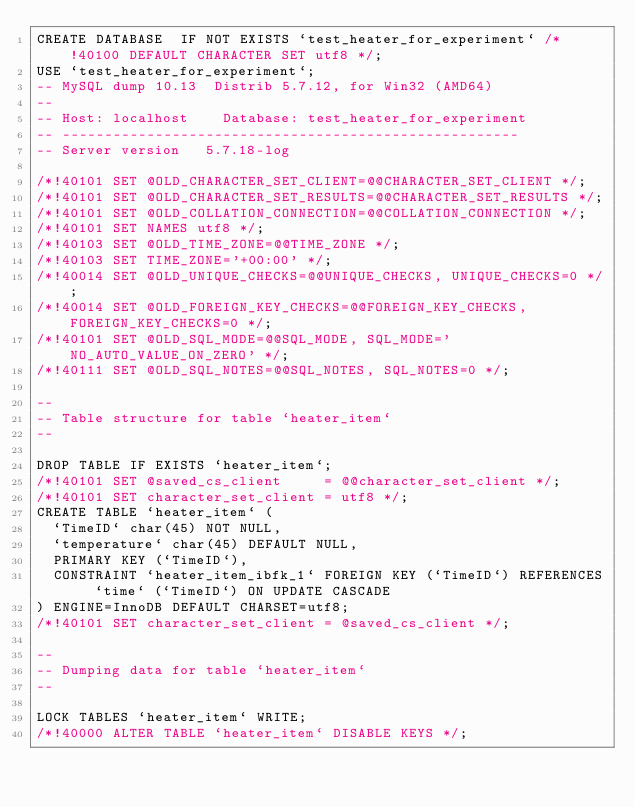<code> <loc_0><loc_0><loc_500><loc_500><_SQL_>CREATE DATABASE  IF NOT EXISTS `test_heater_for_experiment` /*!40100 DEFAULT CHARACTER SET utf8 */;
USE `test_heater_for_experiment`;
-- MySQL dump 10.13  Distrib 5.7.12, for Win32 (AMD64)
--
-- Host: localhost    Database: test_heater_for_experiment
-- ------------------------------------------------------
-- Server version	5.7.18-log

/*!40101 SET @OLD_CHARACTER_SET_CLIENT=@@CHARACTER_SET_CLIENT */;
/*!40101 SET @OLD_CHARACTER_SET_RESULTS=@@CHARACTER_SET_RESULTS */;
/*!40101 SET @OLD_COLLATION_CONNECTION=@@COLLATION_CONNECTION */;
/*!40101 SET NAMES utf8 */;
/*!40103 SET @OLD_TIME_ZONE=@@TIME_ZONE */;
/*!40103 SET TIME_ZONE='+00:00' */;
/*!40014 SET @OLD_UNIQUE_CHECKS=@@UNIQUE_CHECKS, UNIQUE_CHECKS=0 */;
/*!40014 SET @OLD_FOREIGN_KEY_CHECKS=@@FOREIGN_KEY_CHECKS, FOREIGN_KEY_CHECKS=0 */;
/*!40101 SET @OLD_SQL_MODE=@@SQL_MODE, SQL_MODE='NO_AUTO_VALUE_ON_ZERO' */;
/*!40111 SET @OLD_SQL_NOTES=@@SQL_NOTES, SQL_NOTES=0 */;

--
-- Table structure for table `heater_item`
--

DROP TABLE IF EXISTS `heater_item`;
/*!40101 SET @saved_cs_client     = @@character_set_client */;
/*!40101 SET character_set_client = utf8 */;
CREATE TABLE `heater_item` (
  `TimeID` char(45) NOT NULL,
  `temperature` char(45) DEFAULT NULL,
  PRIMARY KEY (`TimeID`),
  CONSTRAINT `heater_item_ibfk_1` FOREIGN KEY (`TimeID`) REFERENCES `time` (`TimeID`) ON UPDATE CASCADE
) ENGINE=InnoDB DEFAULT CHARSET=utf8;
/*!40101 SET character_set_client = @saved_cs_client */;

--
-- Dumping data for table `heater_item`
--

LOCK TABLES `heater_item` WRITE;
/*!40000 ALTER TABLE `heater_item` DISABLE KEYS */;</code> 